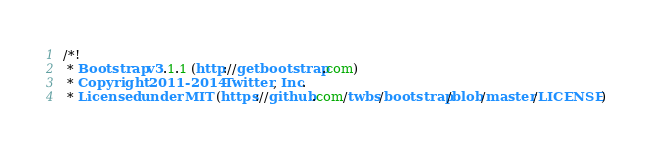Convert code to text. <code><loc_0><loc_0><loc_500><loc_500><_CSS_>/*!
 * Bootstrap v3.1.1 (http://getbootstrap.com)
 * Copyright 2011-2014 Twitter, Inc.
 * Licensed under MIT (https://github.com/twbs/bootstrap/blob/master/LICENSE)</code> 